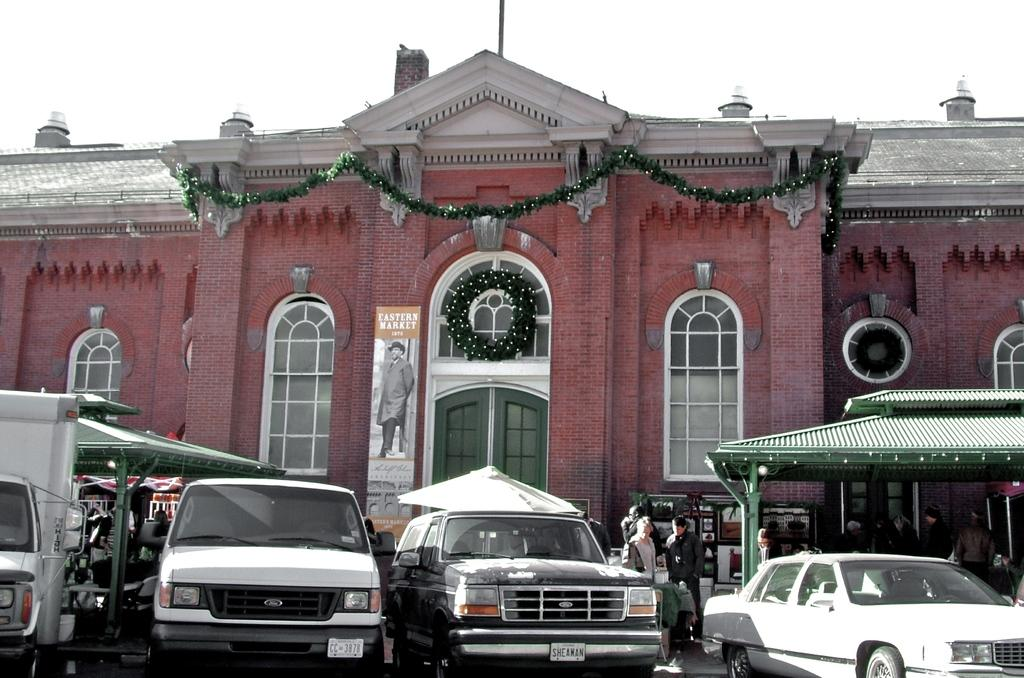What types of objects are present in the image? There are vehicles, a group of people, tents, a building with windows, and a banner in the image. Can you describe the people in the image? There is a group of people standing on the ground in the image. What is the architectural feature of the building in the image? The building in the image has windows. What is attached to the building in the image? There is a banner in the image. What can be seen in the background of the image? The sky is visible in the background of the image. What type of plants can be seen growing on the crow in the image? There is no crow present in the image, and therefore no plants growing on it. How many farm animals are visible in the image? There are no farm animals present in the image. 